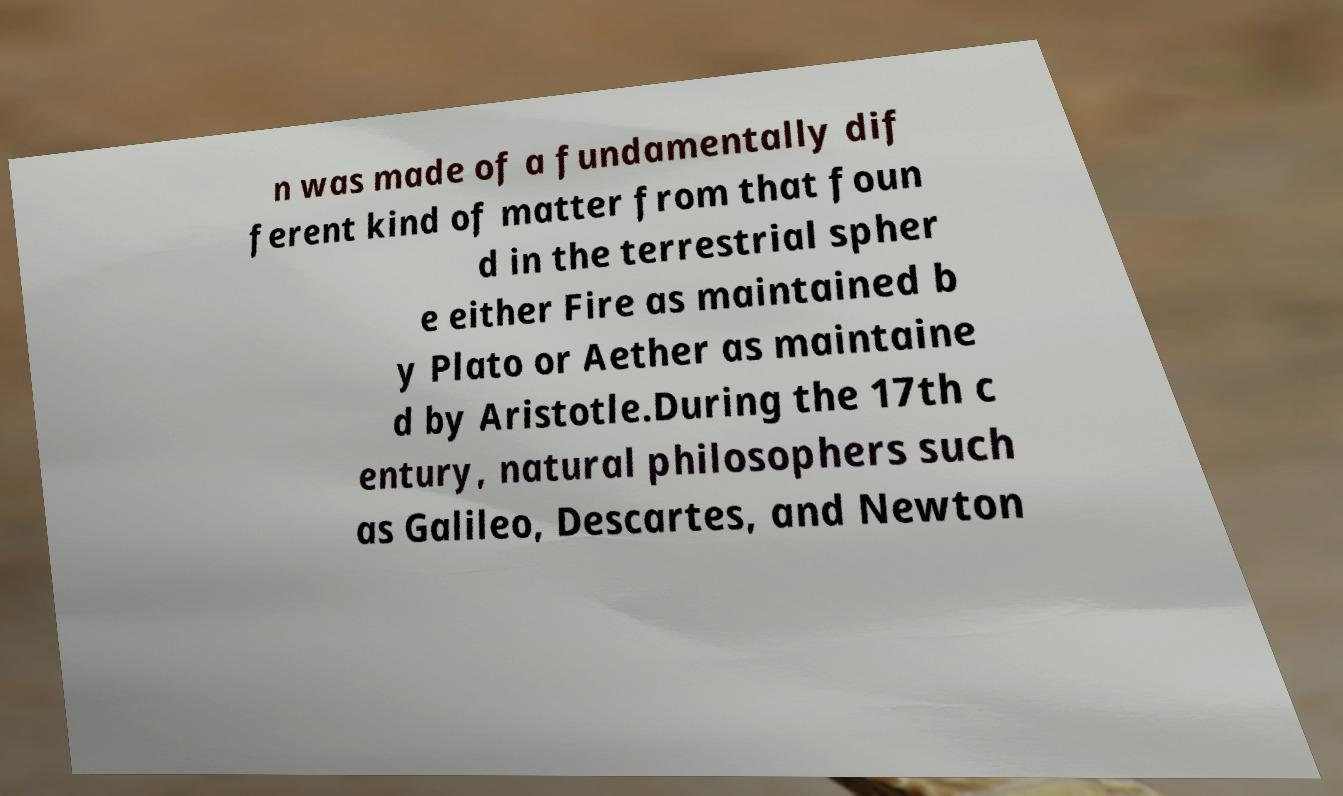Can you accurately transcribe the text from the provided image for me? n was made of a fundamentally dif ferent kind of matter from that foun d in the terrestrial spher e either Fire as maintained b y Plato or Aether as maintaine d by Aristotle.During the 17th c entury, natural philosophers such as Galileo, Descartes, and Newton 